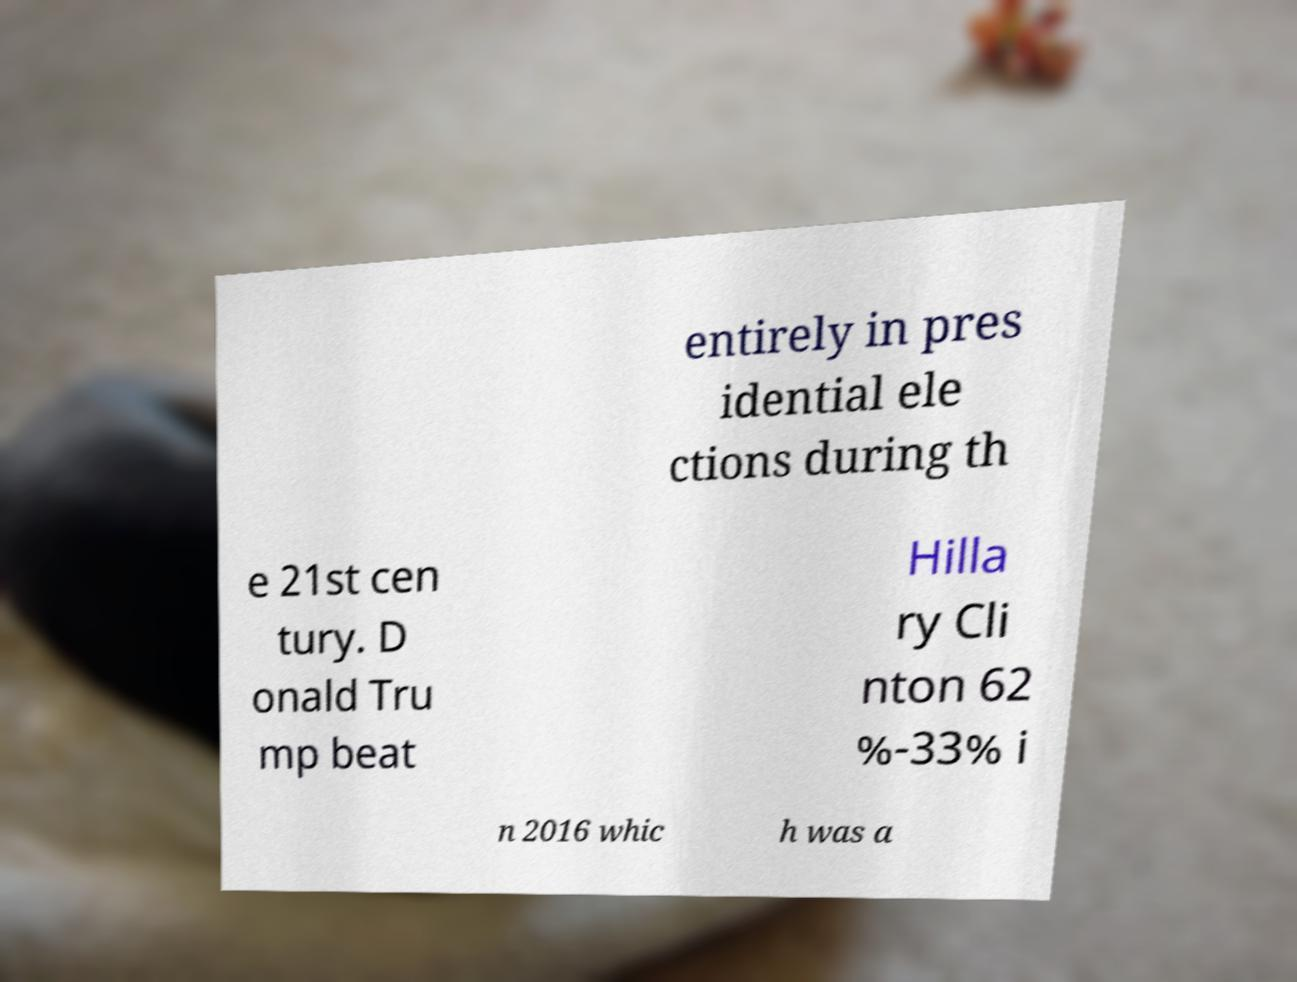For documentation purposes, I need the text within this image transcribed. Could you provide that? entirely in pres idential ele ctions during th e 21st cen tury. D onald Tru mp beat Hilla ry Cli nton 62 %-33% i n 2016 whic h was a 